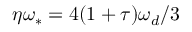<formula> <loc_0><loc_0><loc_500><loc_500>\eta \omega _ { \ast } = 4 ( 1 + \tau ) \omega _ { d } / 3</formula> 